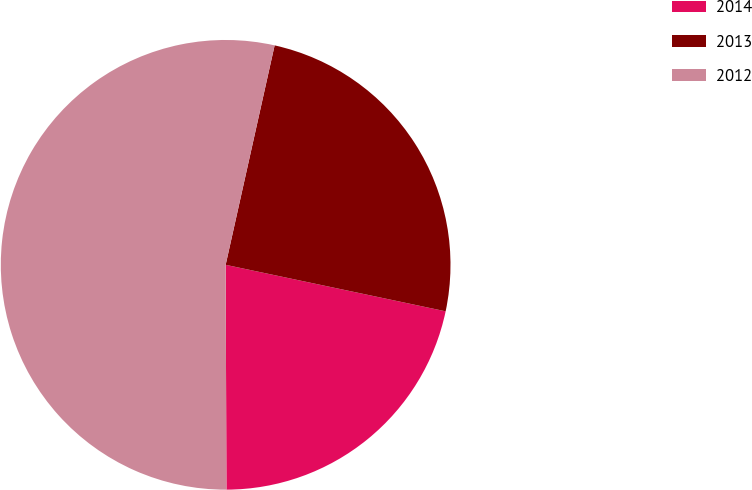Convert chart to OTSL. <chart><loc_0><loc_0><loc_500><loc_500><pie_chart><fcel>2014<fcel>2013<fcel>2012<nl><fcel>21.63%<fcel>24.82%<fcel>53.55%<nl></chart> 